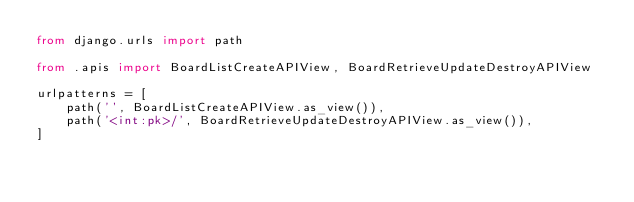<code> <loc_0><loc_0><loc_500><loc_500><_Python_>from django.urls import path

from .apis import BoardListCreateAPIView, BoardRetrieveUpdateDestroyAPIView

urlpatterns = [
    path('', BoardListCreateAPIView.as_view()),
    path('<int:pk>/', BoardRetrieveUpdateDestroyAPIView.as_view()),
]
</code> 